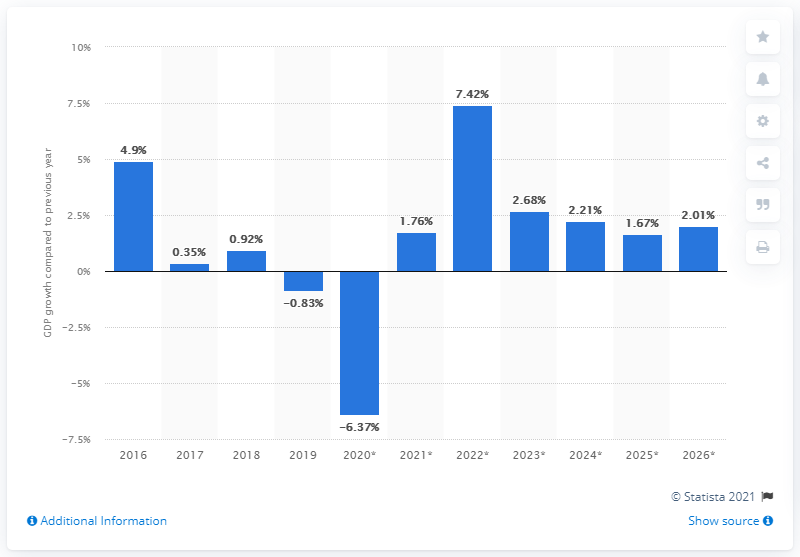Draw attention to some important aspects in this diagram. Oman's real GDP grew from 2016 to 2026. 